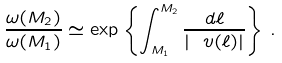Convert formula to latex. <formula><loc_0><loc_0><loc_500><loc_500>\frac { \omega ( M _ { 2 } ) } { \omega ( M _ { 1 } ) } \simeq \exp \left \{ \int _ { M _ { 1 } } ^ { M _ { 2 } } \frac { d \ell } { | \ v ( \ell ) | } \right \} \, .</formula> 